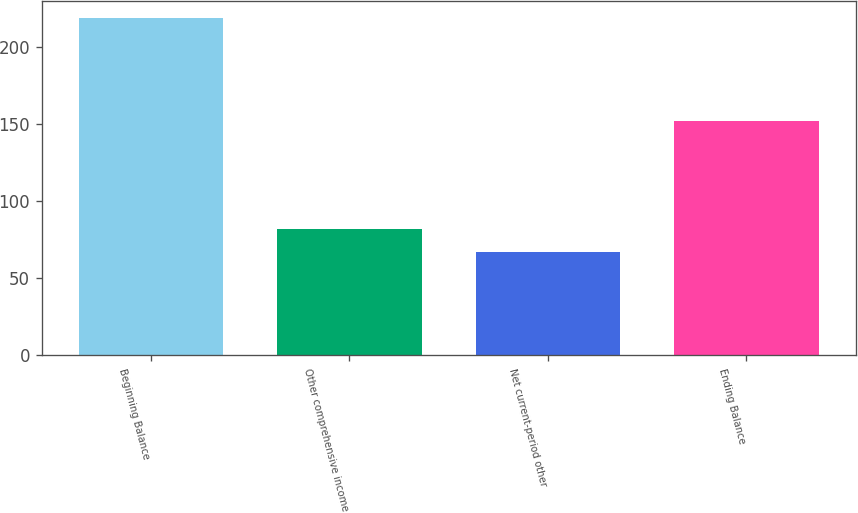<chart> <loc_0><loc_0><loc_500><loc_500><bar_chart><fcel>Beginning Balance<fcel>Other comprehensive income<fcel>Net current-period other<fcel>Ending Balance<nl><fcel>219<fcel>82.2<fcel>67<fcel>152<nl></chart> 